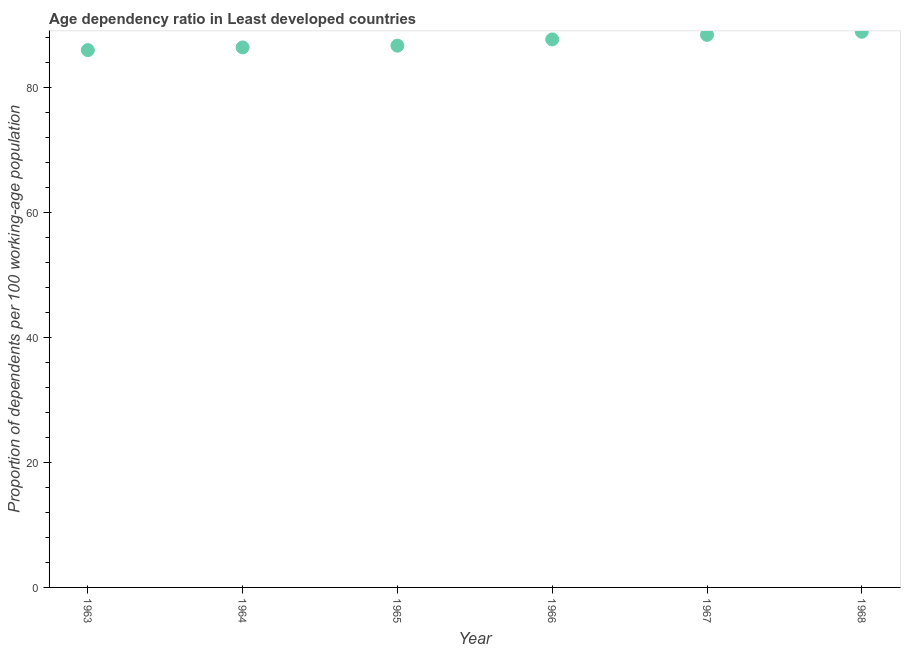What is the age dependency ratio in 1963?
Keep it short and to the point. 85.97. Across all years, what is the maximum age dependency ratio?
Offer a very short reply. 88.91. Across all years, what is the minimum age dependency ratio?
Keep it short and to the point. 85.97. In which year was the age dependency ratio maximum?
Provide a succinct answer. 1968. In which year was the age dependency ratio minimum?
Keep it short and to the point. 1963. What is the sum of the age dependency ratio?
Provide a succinct answer. 524.08. What is the difference between the age dependency ratio in 1964 and 1966?
Ensure brevity in your answer.  -1.28. What is the average age dependency ratio per year?
Provide a succinct answer. 87.35. What is the median age dependency ratio?
Your answer should be compact. 87.19. In how many years, is the age dependency ratio greater than 4 ?
Your answer should be very brief. 6. What is the ratio of the age dependency ratio in 1964 to that in 1966?
Give a very brief answer. 0.99. Is the age dependency ratio in 1964 less than that in 1967?
Provide a short and direct response. Yes. Is the difference between the age dependency ratio in 1965 and 1966 greater than the difference between any two years?
Your response must be concise. No. What is the difference between the highest and the second highest age dependency ratio?
Your response must be concise. 0.5. Is the sum of the age dependency ratio in 1963 and 1966 greater than the maximum age dependency ratio across all years?
Your response must be concise. Yes. What is the difference between the highest and the lowest age dependency ratio?
Ensure brevity in your answer.  2.94. In how many years, is the age dependency ratio greater than the average age dependency ratio taken over all years?
Make the answer very short. 3. Does the age dependency ratio monotonically increase over the years?
Your response must be concise. Yes. How many dotlines are there?
Your answer should be compact. 1. How many years are there in the graph?
Offer a terse response. 6. What is the title of the graph?
Your answer should be compact. Age dependency ratio in Least developed countries. What is the label or title of the X-axis?
Offer a very short reply. Year. What is the label or title of the Y-axis?
Your response must be concise. Proportion of dependents per 100 working-age population. What is the Proportion of dependents per 100 working-age population in 1963?
Keep it short and to the point. 85.97. What is the Proportion of dependents per 100 working-age population in 1964?
Ensure brevity in your answer.  86.41. What is the Proportion of dependents per 100 working-age population in 1965?
Make the answer very short. 86.69. What is the Proportion of dependents per 100 working-age population in 1966?
Offer a terse response. 87.69. What is the Proportion of dependents per 100 working-age population in 1967?
Offer a terse response. 88.42. What is the Proportion of dependents per 100 working-age population in 1968?
Your answer should be compact. 88.91. What is the difference between the Proportion of dependents per 100 working-age population in 1963 and 1964?
Provide a succinct answer. -0.43. What is the difference between the Proportion of dependents per 100 working-age population in 1963 and 1965?
Your answer should be compact. -0.71. What is the difference between the Proportion of dependents per 100 working-age population in 1963 and 1966?
Offer a terse response. -1.71. What is the difference between the Proportion of dependents per 100 working-age population in 1963 and 1967?
Keep it short and to the point. -2.44. What is the difference between the Proportion of dependents per 100 working-age population in 1963 and 1968?
Give a very brief answer. -2.94. What is the difference between the Proportion of dependents per 100 working-age population in 1964 and 1965?
Ensure brevity in your answer.  -0.28. What is the difference between the Proportion of dependents per 100 working-age population in 1964 and 1966?
Make the answer very short. -1.28. What is the difference between the Proportion of dependents per 100 working-age population in 1964 and 1967?
Give a very brief answer. -2.01. What is the difference between the Proportion of dependents per 100 working-age population in 1964 and 1968?
Provide a succinct answer. -2.51. What is the difference between the Proportion of dependents per 100 working-age population in 1965 and 1966?
Ensure brevity in your answer.  -1. What is the difference between the Proportion of dependents per 100 working-age population in 1965 and 1967?
Give a very brief answer. -1.73. What is the difference between the Proportion of dependents per 100 working-age population in 1965 and 1968?
Provide a short and direct response. -2.23. What is the difference between the Proportion of dependents per 100 working-age population in 1966 and 1967?
Offer a very short reply. -0.73. What is the difference between the Proportion of dependents per 100 working-age population in 1966 and 1968?
Provide a short and direct response. -1.23. What is the difference between the Proportion of dependents per 100 working-age population in 1967 and 1968?
Your answer should be very brief. -0.5. What is the ratio of the Proportion of dependents per 100 working-age population in 1963 to that in 1965?
Your answer should be compact. 0.99. What is the ratio of the Proportion of dependents per 100 working-age population in 1963 to that in 1966?
Offer a terse response. 0.98. What is the ratio of the Proportion of dependents per 100 working-age population in 1963 to that in 1967?
Make the answer very short. 0.97. What is the ratio of the Proportion of dependents per 100 working-age population in 1963 to that in 1968?
Ensure brevity in your answer.  0.97. What is the ratio of the Proportion of dependents per 100 working-age population in 1964 to that in 1965?
Keep it short and to the point. 1. What is the ratio of the Proportion of dependents per 100 working-age population in 1964 to that in 1966?
Provide a short and direct response. 0.98. What is the ratio of the Proportion of dependents per 100 working-age population in 1964 to that in 1967?
Keep it short and to the point. 0.98. What is the ratio of the Proportion of dependents per 100 working-age population in 1964 to that in 1968?
Keep it short and to the point. 0.97. What is the ratio of the Proportion of dependents per 100 working-age population in 1965 to that in 1966?
Give a very brief answer. 0.99. What is the ratio of the Proportion of dependents per 100 working-age population in 1965 to that in 1967?
Your response must be concise. 0.98. What is the ratio of the Proportion of dependents per 100 working-age population in 1965 to that in 1968?
Keep it short and to the point. 0.97. What is the ratio of the Proportion of dependents per 100 working-age population in 1966 to that in 1968?
Offer a terse response. 0.99. What is the ratio of the Proportion of dependents per 100 working-age population in 1967 to that in 1968?
Your answer should be compact. 0.99. 